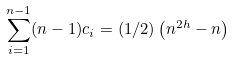Convert formula to latex. <formula><loc_0><loc_0><loc_500><loc_500>\sum _ { i = 1 } ^ { n - 1 } ( n - 1 ) c _ { i } = ( 1 / 2 ) \left ( n ^ { 2 h } - n \right )</formula> 